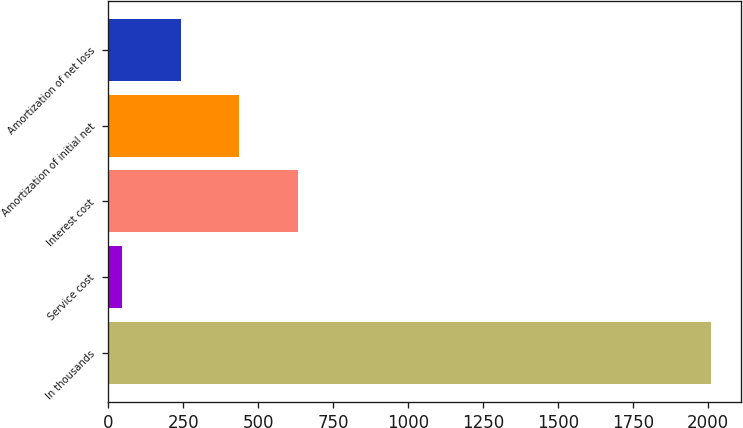Convert chart to OTSL. <chart><loc_0><loc_0><loc_500><loc_500><bar_chart><fcel>In thousands<fcel>Service cost<fcel>Interest cost<fcel>Amortization of initial net<fcel>Amortization of net loss<nl><fcel>2009<fcel>44<fcel>633.5<fcel>437<fcel>240.5<nl></chart> 